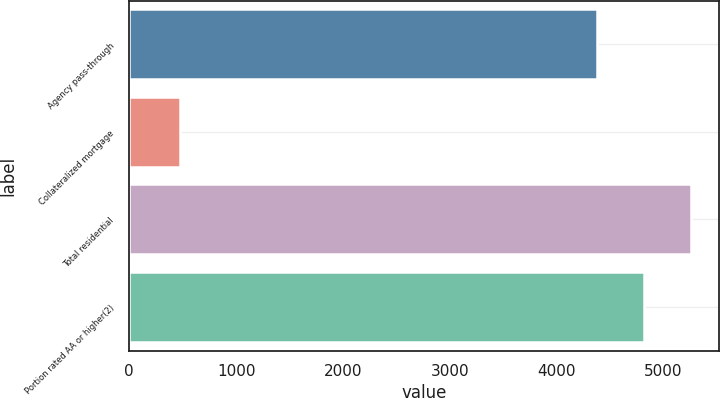<chart> <loc_0><loc_0><loc_500><loc_500><bar_chart><fcel>Agency pass-through<fcel>Collateralized mortgage<fcel>Total residential<fcel>Portion rated AA or higher(2)<nl><fcel>4382<fcel>479<fcel>5258.4<fcel>4820.2<nl></chart> 